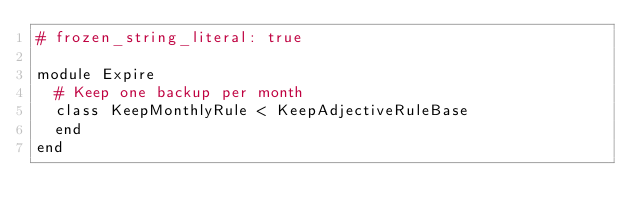<code> <loc_0><loc_0><loc_500><loc_500><_Ruby_># frozen_string_literal: true

module Expire
  # Keep one backup per month
  class KeepMonthlyRule < KeepAdjectiveRuleBase
  end
end
</code> 